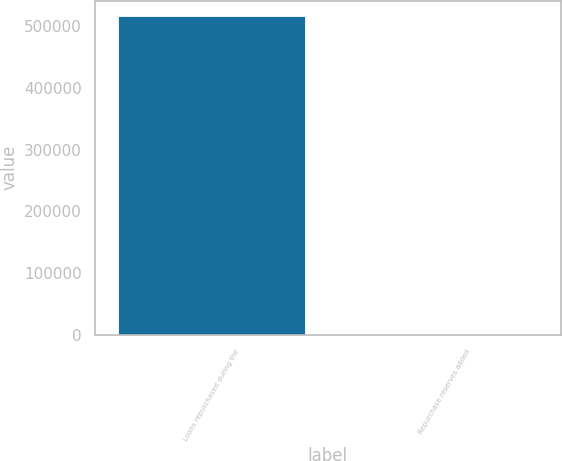<chart> <loc_0><loc_0><loc_500><loc_500><bar_chart><fcel>Loans repurchased during the<fcel>Repurchase reserves added<nl><fcel>515370<fcel>14.38<nl></chart> 